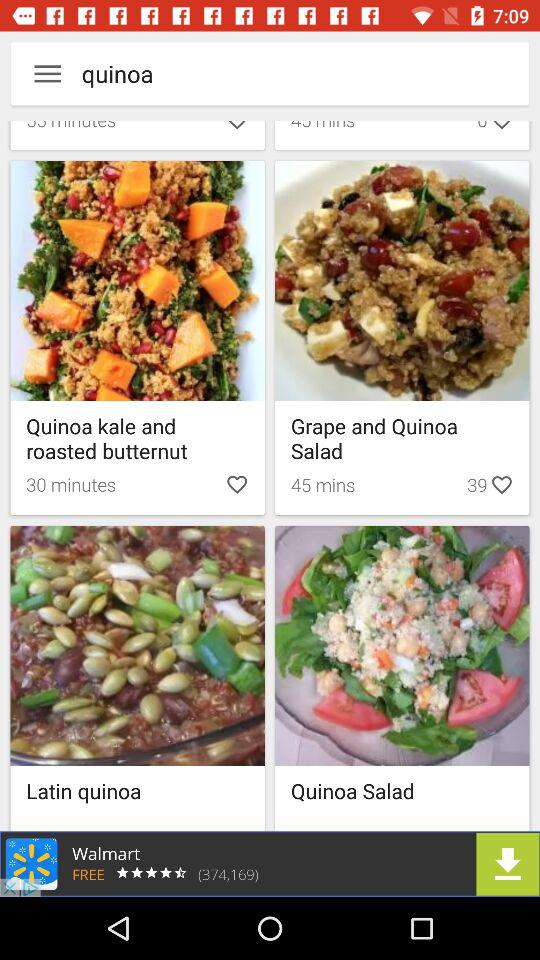What are the different quinoa dishes? The different quinoa dishes are "Quinoa kale and roasted butternut", "Grape and Quinoa Salad", "Latin quinoa" and "Quinoa Salad". 